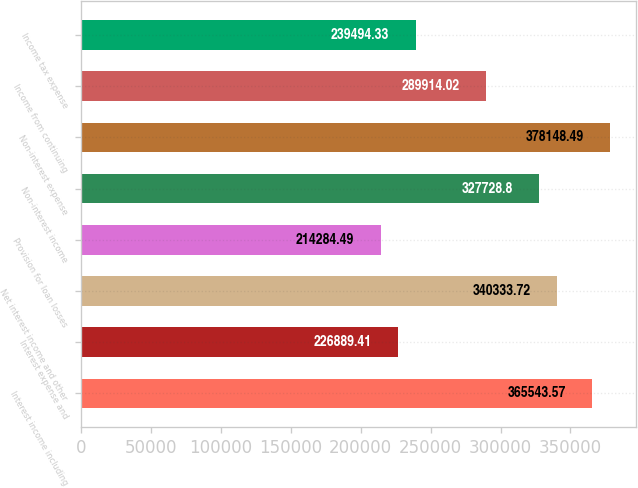Convert chart to OTSL. <chart><loc_0><loc_0><loc_500><loc_500><bar_chart><fcel>Interest income including<fcel>Interest expense and<fcel>Net interest income and other<fcel>Provision for loan losses<fcel>Non-interest income<fcel>Non-interest expense<fcel>Income from continuing<fcel>Income tax expense<nl><fcel>365544<fcel>226889<fcel>340334<fcel>214284<fcel>327729<fcel>378148<fcel>289914<fcel>239494<nl></chart> 